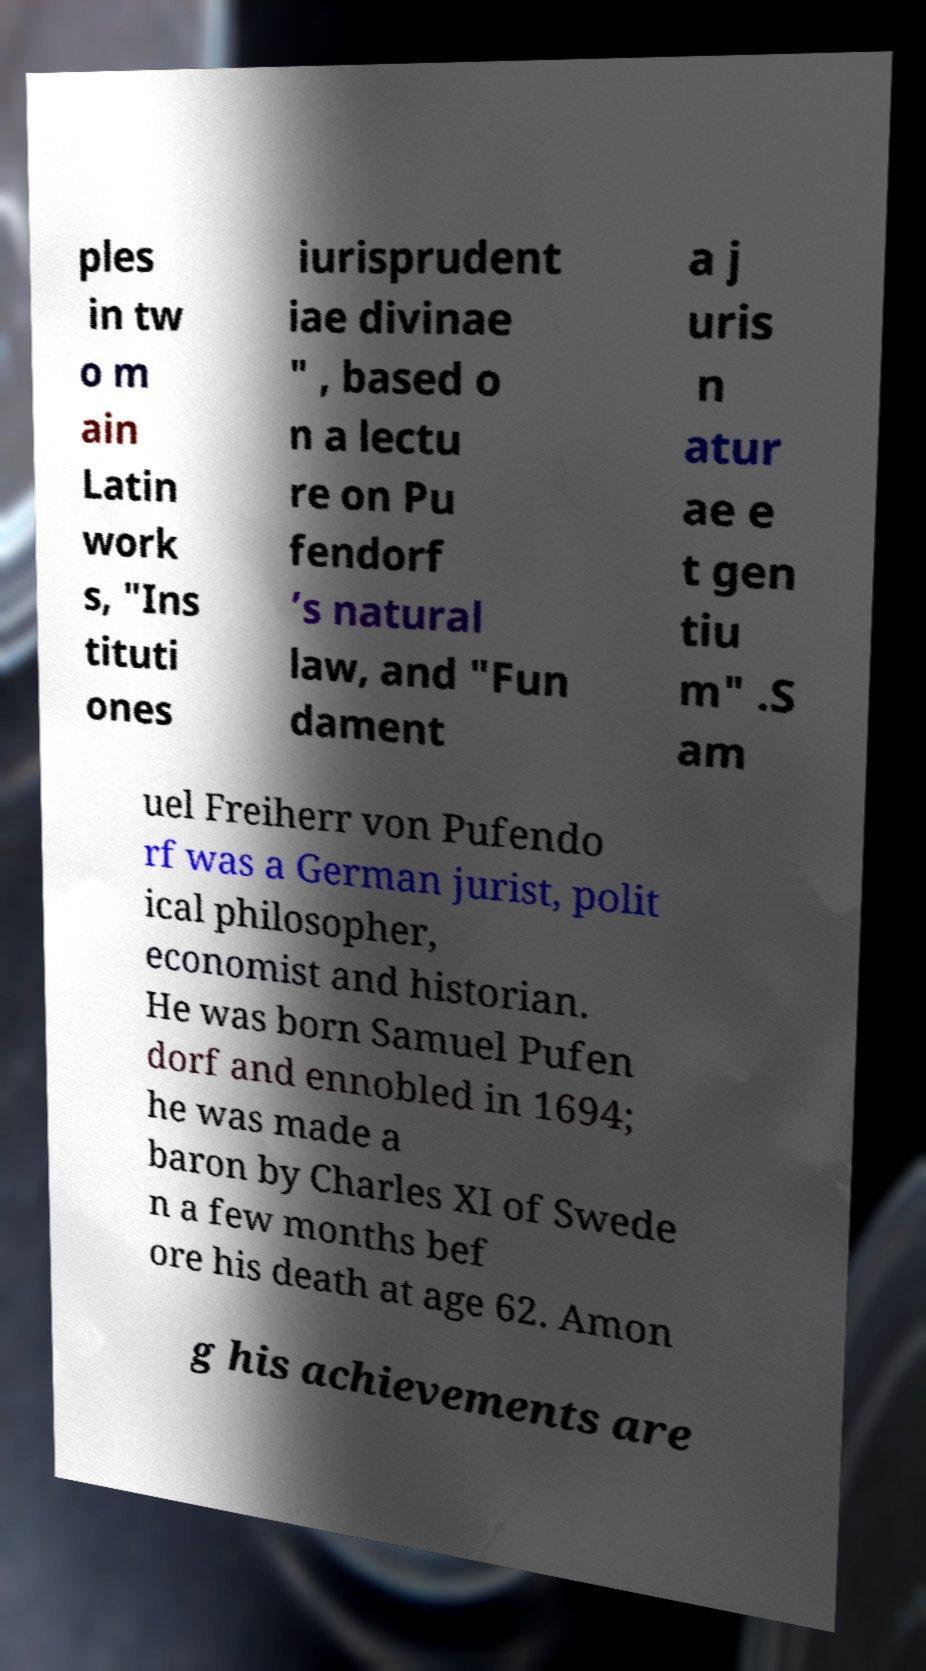For documentation purposes, I need the text within this image transcribed. Could you provide that? ples in tw o m ain Latin work s, "Ins tituti ones iurisprudent iae divinae " , based o n a lectu re on Pu fendorf ’s natural law, and "Fun dament a j uris n atur ae e t gen tiu m" .S am uel Freiherr von Pufendo rf was a German jurist, polit ical philosopher, economist and historian. He was born Samuel Pufen dorf and ennobled in 1694; he was made a baron by Charles XI of Swede n a few months bef ore his death at age 62. Amon g his achievements are 